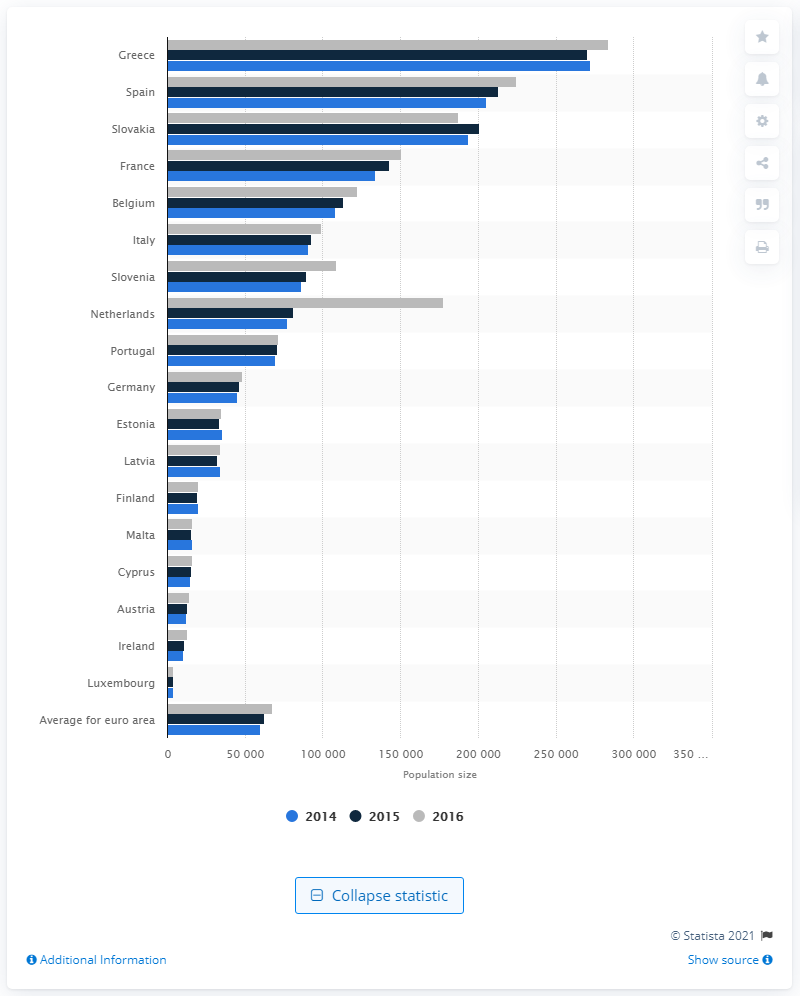Indicate a few pertinent items in this graphic. The average population size for all countries in the eurozone in 2016 was 673,410. 